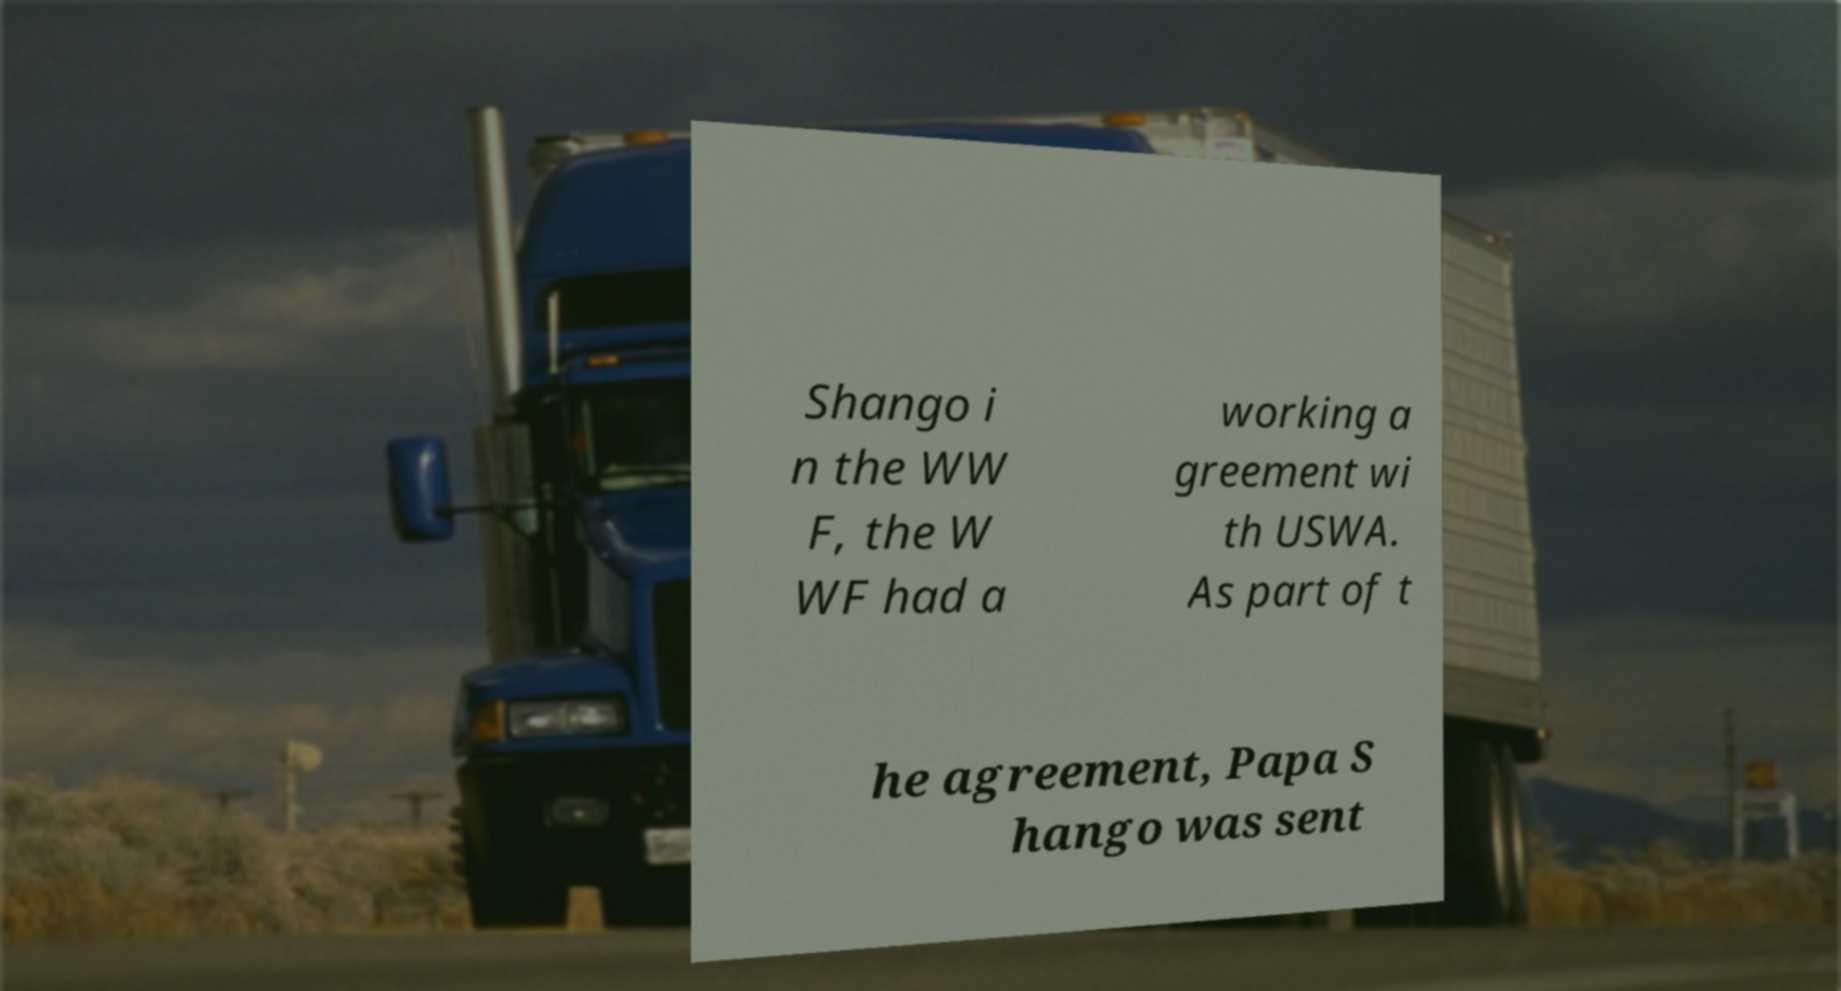Could you extract and type out the text from this image? Shango i n the WW F, the W WF had a working a greement wi th USWA. As part of t he agreement, Papa S hango was sent 